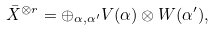Convert formula to latex. <formula><loc_0><loc_0><loc_500><loc_500>\bar { X } ^ { \otimes r } = \oplus _ { \alpha , \alpha ^ { \prime } } V ( \alpha ) \otimes W ( \alpha ^ { \prime } ) ,</formula> 